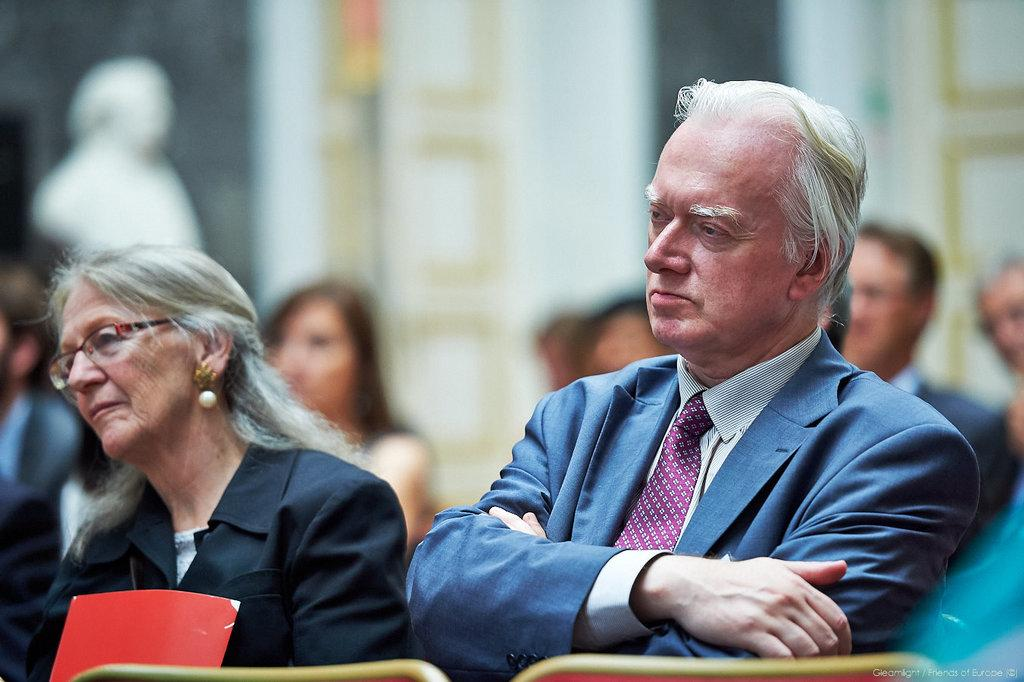What are the people in the image doing? The people in the image are sitting on chairs. Can you describe the background of the image? The background of the image is blurred. What type of government is depicted in the image? There is no indication of any government or political system in the image; it simply shows people sitting on chairs. What unit of measurement is used to determine the length of the copper wire in the image? There is no copper wire or any reference to a unit of measurement in the image. 